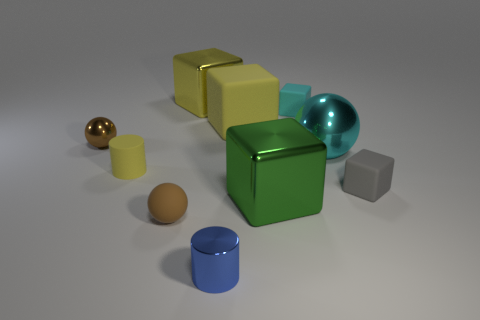Subtract 1 blocks. How many blocks are left? 4 Subtract all green blocks. How many blocks are left? 4 Subtract all cylinders. How many objects are left? 8 Subtract 0 brown blocks. How many objects are left? 10 Subtract all green shiny cylinders. Subtract all big green metal cubes. How many objects are left? 9 Add 3 brown spheres. How many brown spheres are left? 5 Add 6 tiny blue cylinders. How many tiny blue cylinders exist? 7 